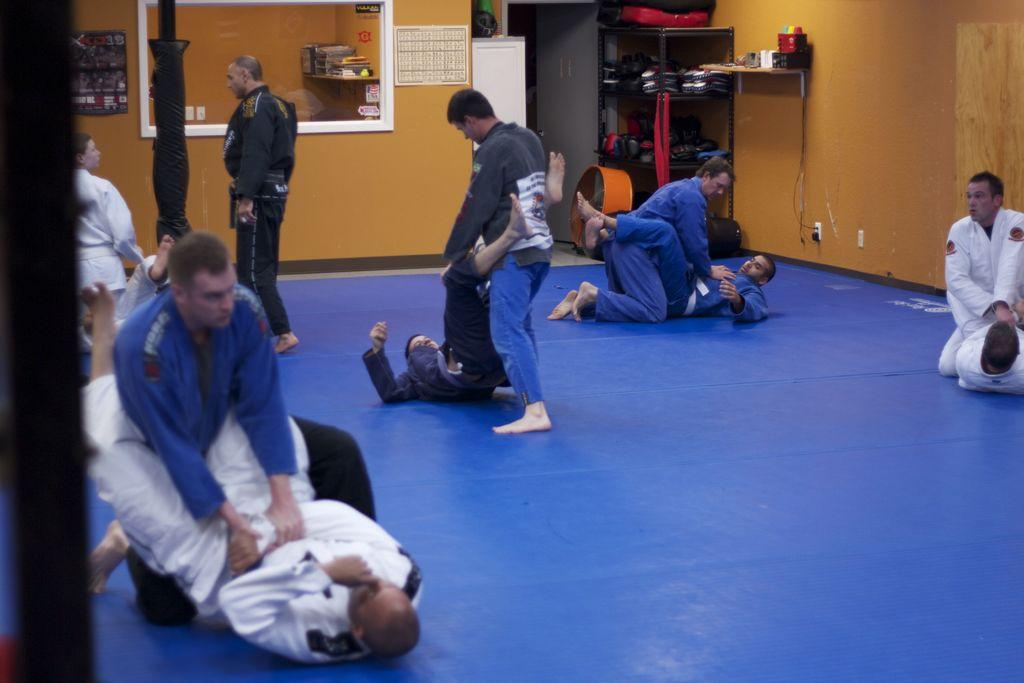How many people are present in the image? There are many people in the image. What can be seen on the wall in the image? There are objects on the wall in the image. What type of furniture or structure is present in the image that holds objects? There are objects on a rack in the image. Is there a needle sticking out of the earth in the image? There is no needle or reference to the earth present in the image. 